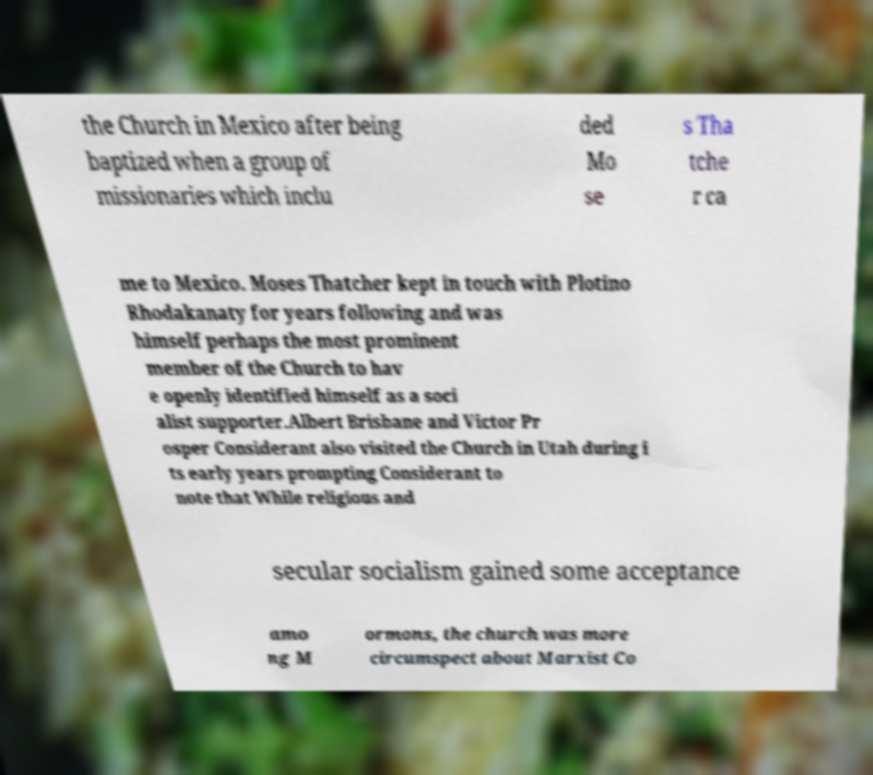Please read and relay the text visible in this image. What does it say? the Church in Mexico after being baptized when a group of missionaries which inclu ded Mo se s Tha tche r ca me to Mexico. Moses Thatcher kept in touch with Plotino Rhodakanaty for years following and was himself perhaps the most prominent member of the Church to hav e openly identified himself as a soci alist supporter.Albert Brisbane and Victor Pr osper Considerant also visited the Church in Utah during i ts early years prompting Considerant to note that While religious and secular socialism gained some acceptance amo ng M ormons, the church was more circumspect about Marxist Co 